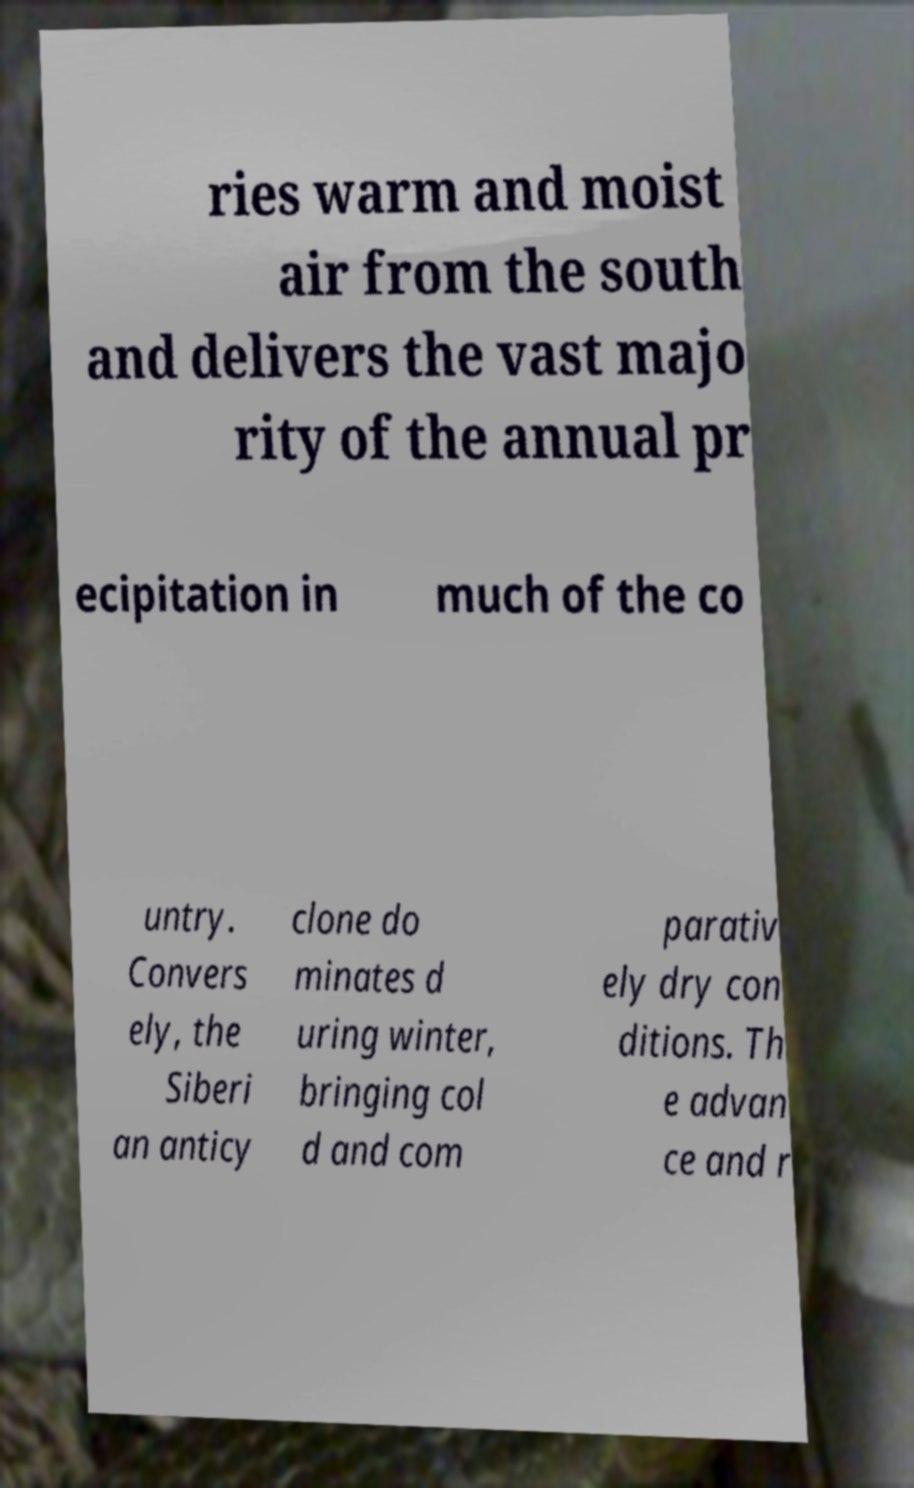Could you assist in decoding the text presented in this image and type it out clearly? ries warm and moist air from the south and delivers the vast majo rity of the annual pr ecipitation in much of the co untry. Convers ely, the Siberi an anticy clone do minates d uring winter, bringing col d and com parativ ely dry con ditions. Th e advan ce and r 